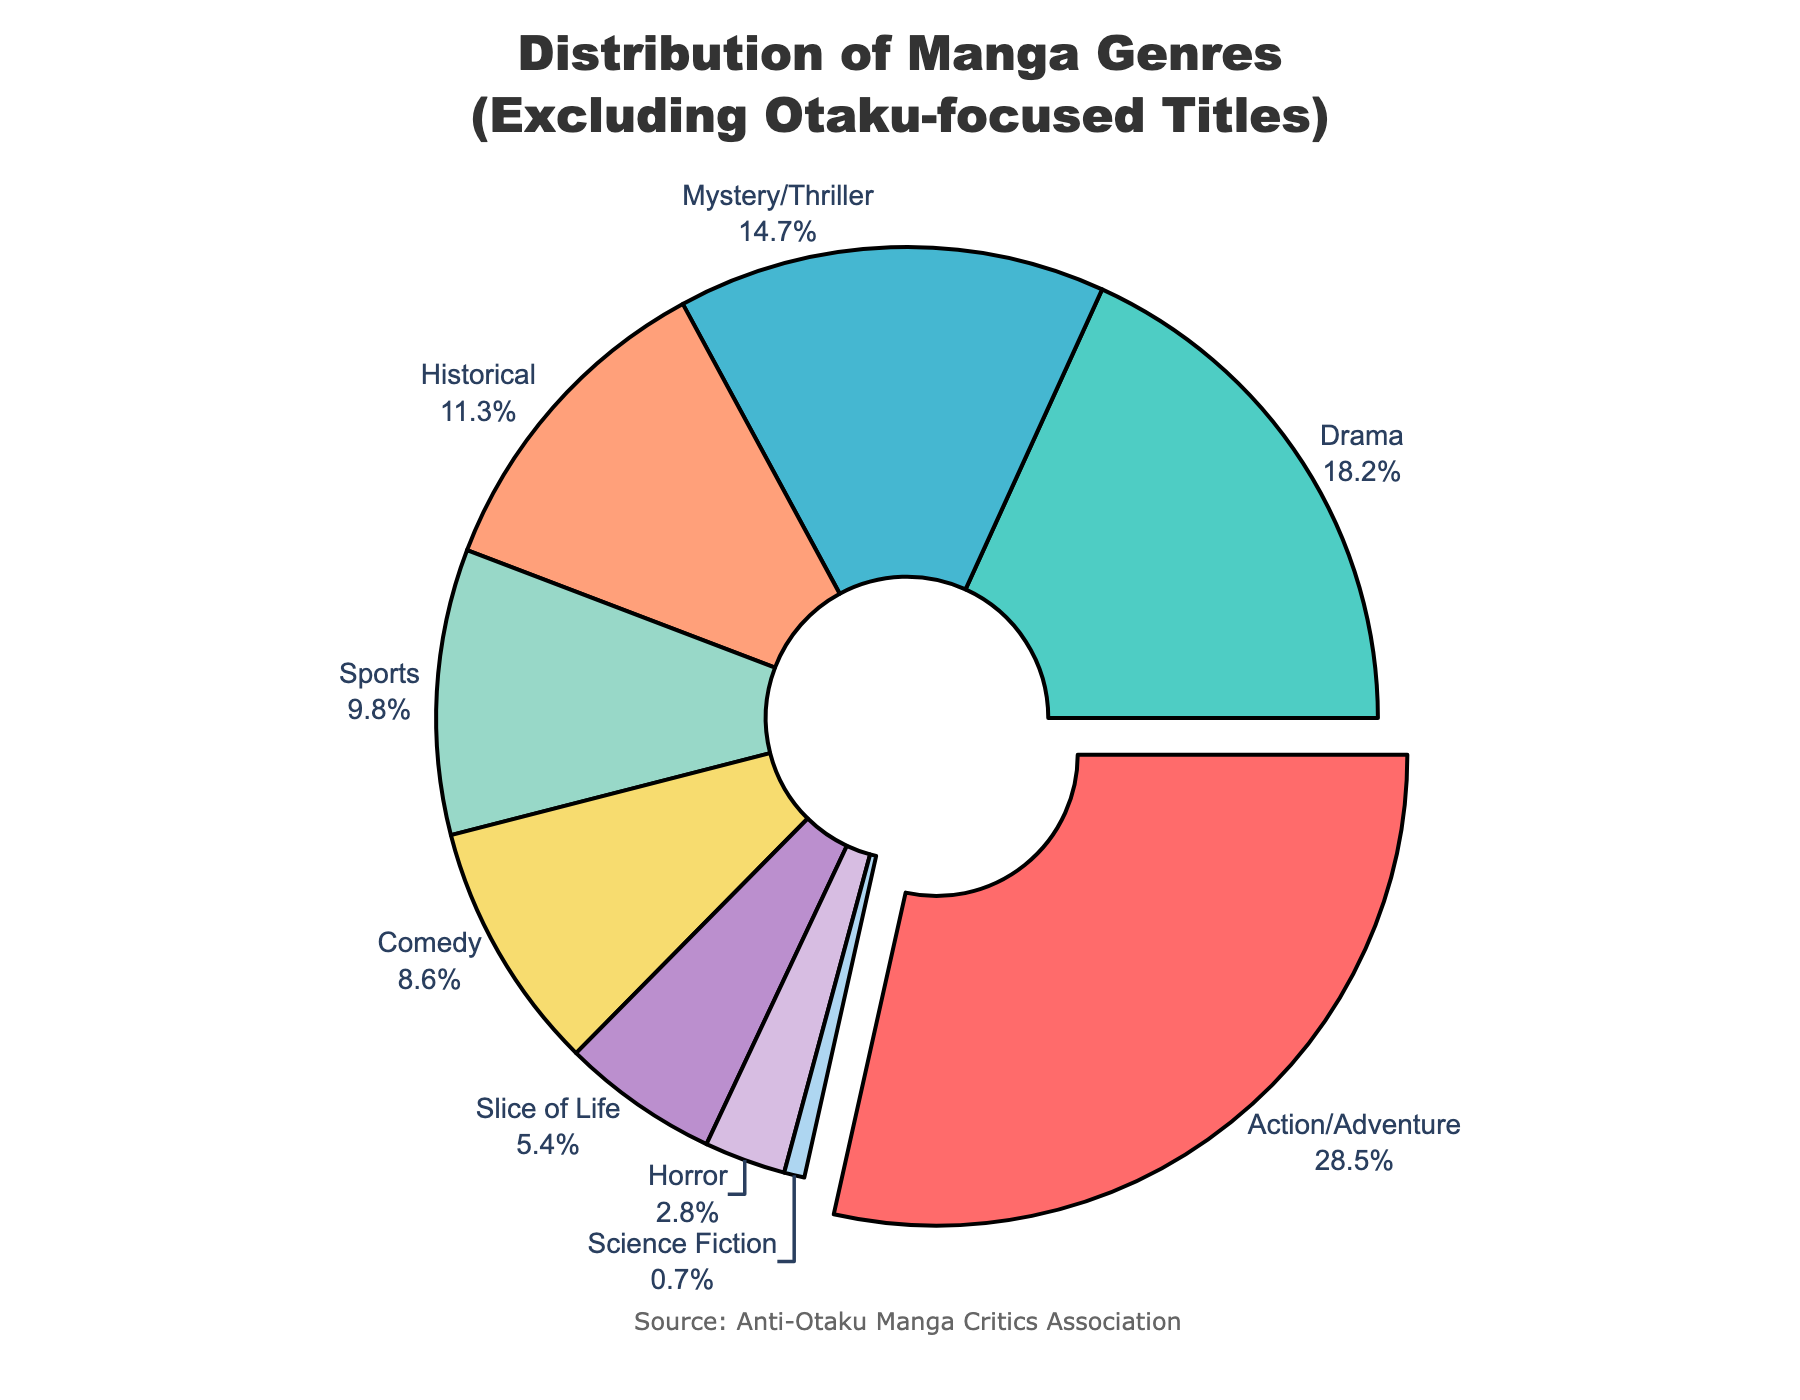What is the percentage of the genre with the highest representation? According to the figure, the segment that is pulled out slightly represents the genre with the highest percentage. Note the percentage and genre name of this segment.
Answer: 28.5% Which genre has a lower percentage, Sports or Comedy? Identify the percentages associated with the genres Sports and Comedy in the chart. Compare these values.
Answer: Comedy How much greater is the percentage of Action/Adventure compared to Horror? Identify the percentages for Action/Adventure and Horror. Subtract the percentage of Horror from Action/Adventure's percentage: 28.5% - 2.8%.
Answer: 25.7% What is the combined percentage of Drama and Mystery/Thriller genres? Note the percentages for Drama and Mystery/Thriller. Add these values: 18.2% + 14.7%.
Answer: 32.9% Which genre is represented with a pale color at the very edge of the chart? Observe the pie chart and identify the color closely associated with a pale color among the segments. This genre has the smallest percentage in the distribution.
Answer: Science Fiction How many genres have a percentage greater than 10%? Count the number of segments in the chart whose percentages exceed 10%.
Answer: 4 Rank the following genres by their percentage in descending order: Historical, Comedy, Slice of Life. Identify the percentages for Historical, Comedy, and Slice of Life. Arrange these in descending order: Historical (11.3%), Comedy (8.6%), Slice of Life (5.4%).
Answer: Historical > Comedy > Slice of Life What is the total percentage of genres excluding Action/Adventure and Drama? Sum the percentages of all genres except for Action/Adventure and Drama: 100% - (28.5% + 18.2%).
Answer: 53.3% Which genre has the highest representation among the following: Horror, Science Fiction, Slice of Life? Compare the percentages of Horror, Science Fiction, and Slice of Life. The genre with the highest percentage among these is indicated in the chart.
Answer: Slice of Life What is the difference between the percentage of the largest segment and the smallest segment? Identify the percentages of the largest (Action/Adventure) and smallest (Science Fiction) segments. Subtract the smallest percentage from the largest: 28.5% - 0.7%.
Answer: 27.8% 